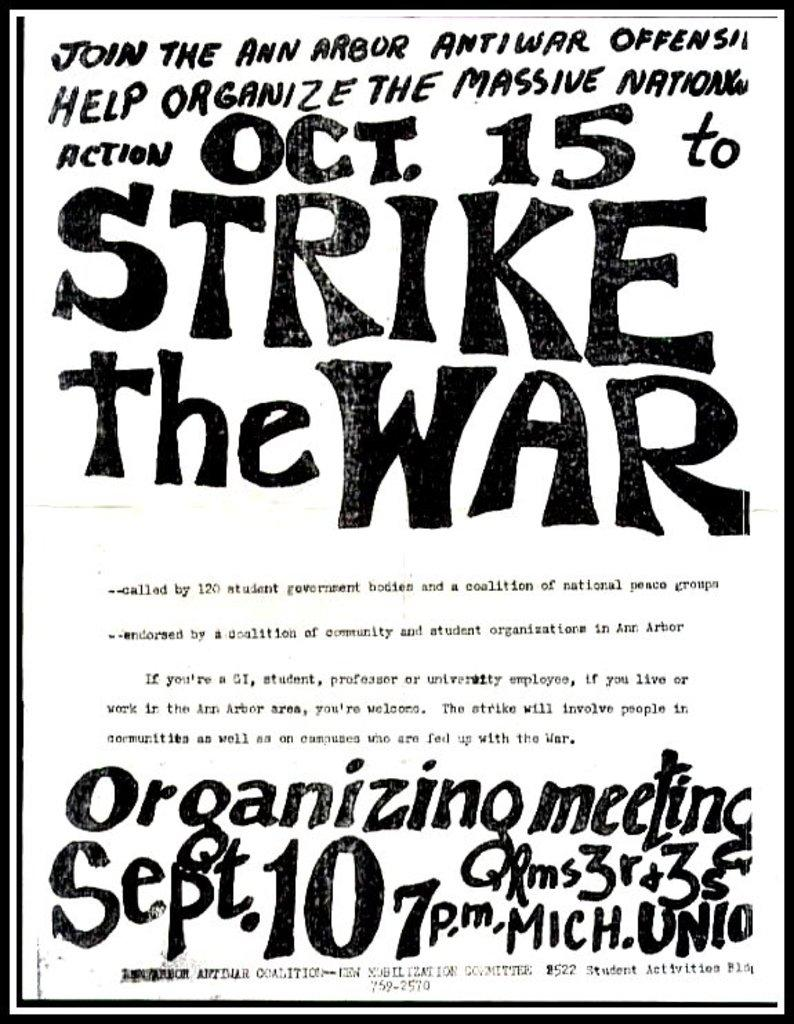<image>
Render a clear and concise summary of the photo. A poster for the ann arbor anti war offensive. 